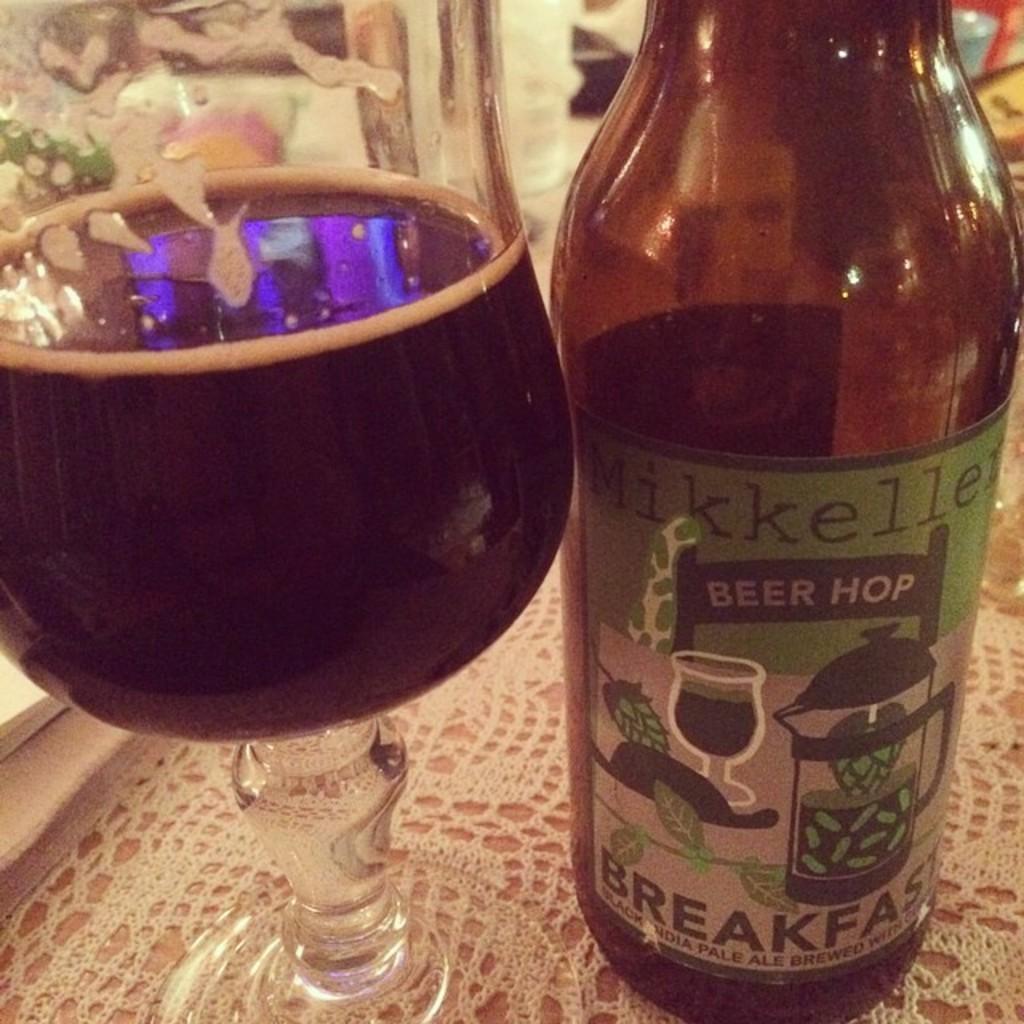Could you give a brief overview of what you see in this image? As we can see in the image there is a glass and bottle on table. 